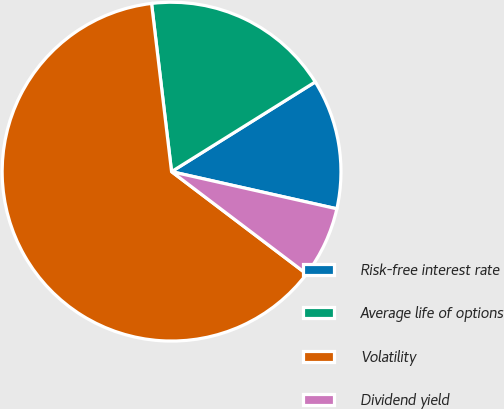Convert chart. <chart><loc_0><loc_0><loc_500><loc_500><pie_chart><fcel>Risk-free interest rate<fcel>Average life of options<fcel>Volatility<fcel>Dividend yield<nl><fcel>12.4%<fcel>18.0%<fcel>62.79%<fcel>6.8%<nl></chart> 